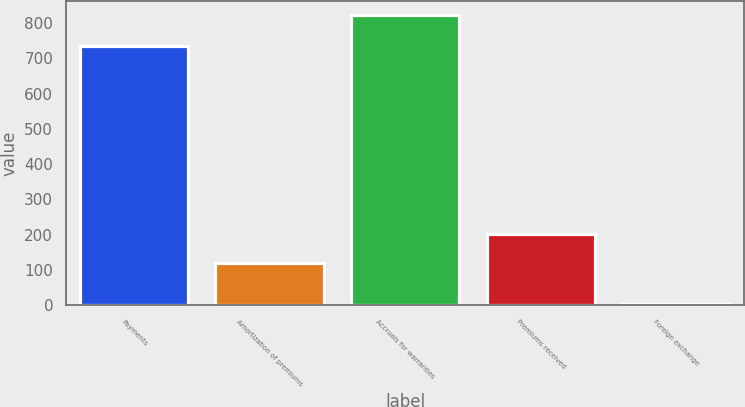Convert chart to OTSL. <chart><loc_0><loc_0><loc_500><loc_500><bar_chart><fcel>Payments<fcel>Amortization of premiums<fcel>Accruals for warranties<fcel>Premiums received<fcel>Foreign exchange<nl><fcel>736<fcel>120<fcel>821<fcel>201.7<fcel>4<nl></chart> 